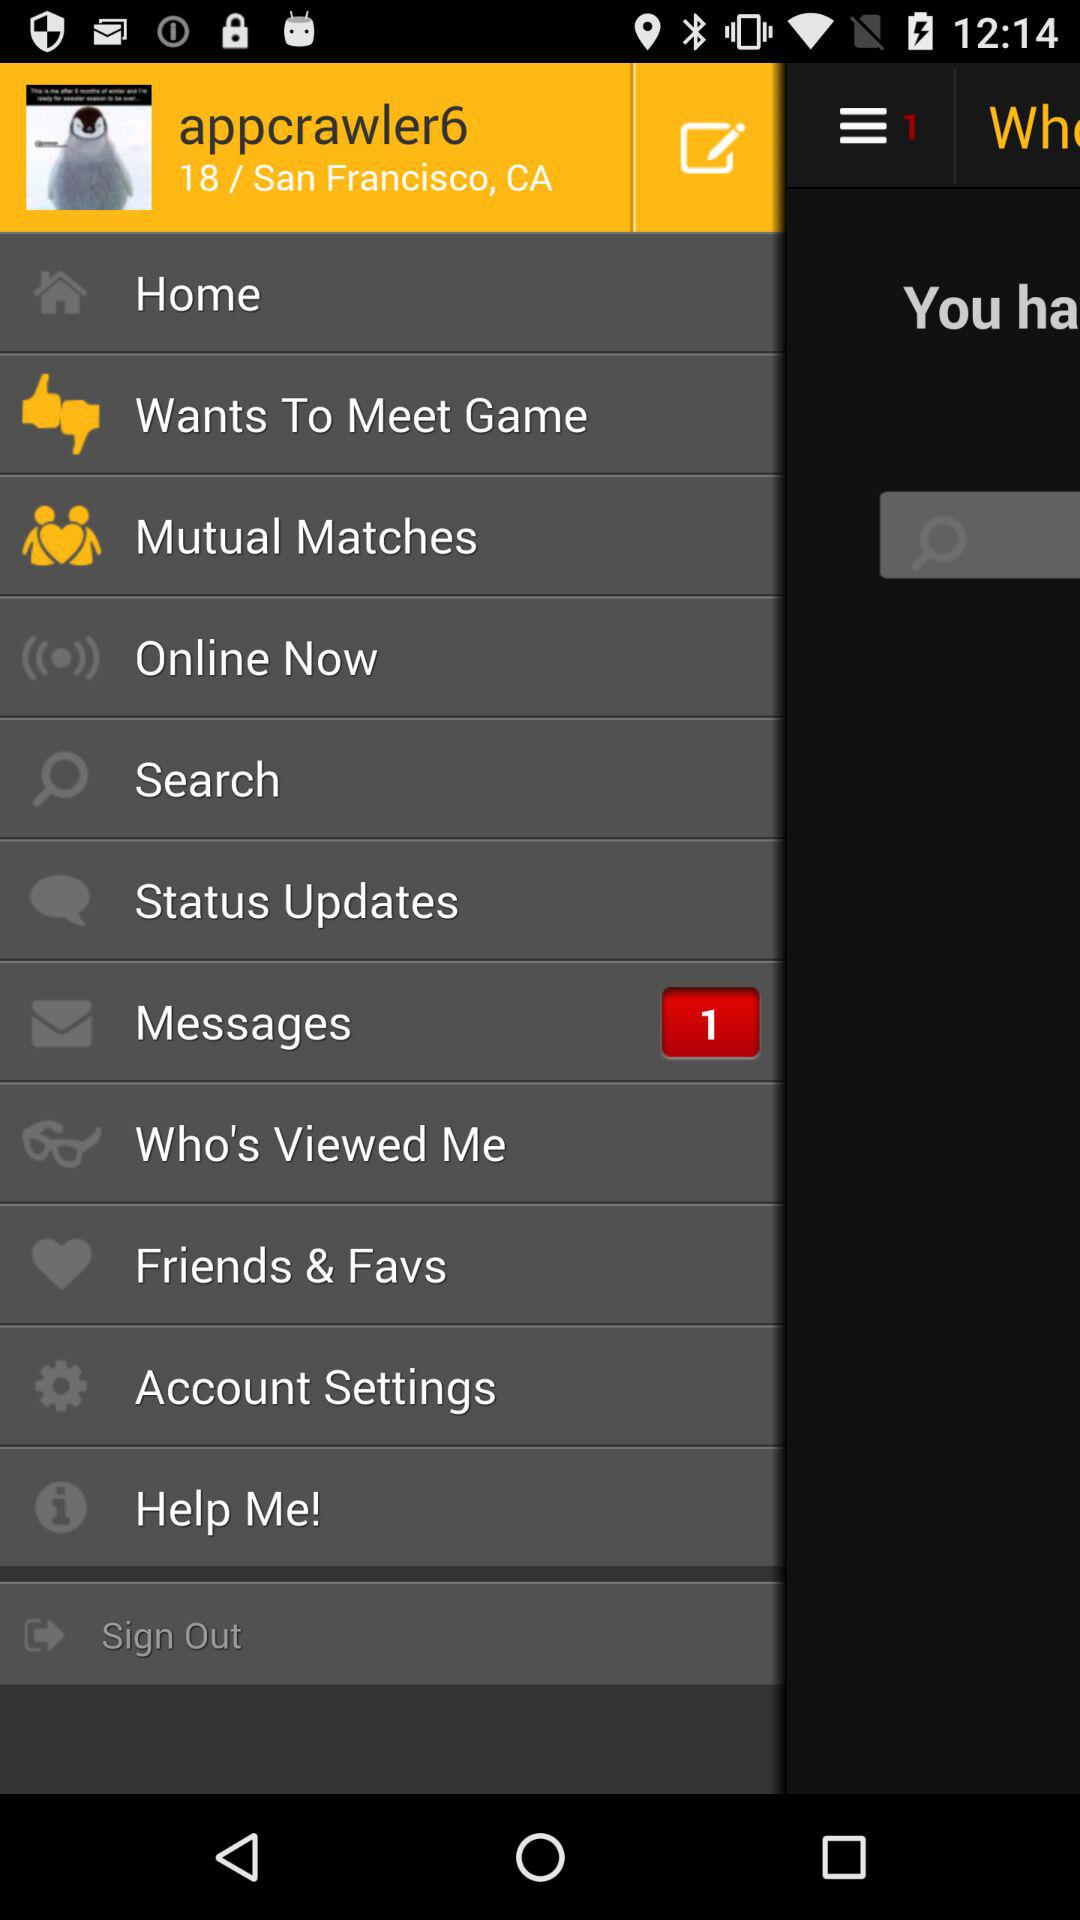What is the username? The username is "appcrawler6". 